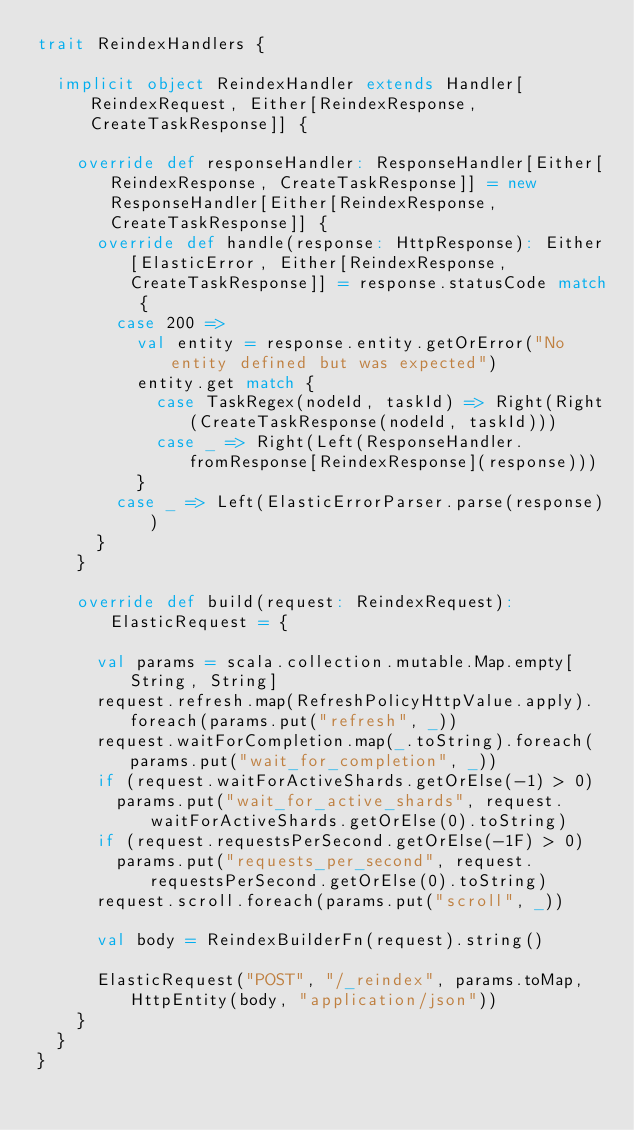<code> <loc_0><loc_0><loc_500><loc_500><_Scala_>trait ReindexHandlers {

  implicit object ReindexHandler extends Handler[ReindexRequest, Either[ReindexResponse, CreateTaskResponse]] {

    override def responseHandler: ResponseHandler[Either[ReindexResponse, CreateTaskResponse]] = new ResponseHandler[Either[ReindexResponse, CreateTaskResponse]] {
      override def handle(response: HttpResponse): Either[ElasticError, Either[ReindexResponse, CreateTaskResponse]] = response.statusCode match {
        case 200 =>
          val entity = response.entity.getOrError("No entity defined but was expected")
          entity.get match {
            case TaskRegex(nodeId, taskId) => Right(Right(CreateTaskResponse(nodeId, taskId)))
            case _ => Right(Left(ResponseHandler.fromResponse[ReindexResponse](response)))
          }
        case _ => Left(ElasticErrorParser.parse(response))
      }
    }

    override def build(request: ReindexRequest): ElasticRequest = {

      val params = scala.collection.mutable.Map.empty[String, String]
      request.refresh.map(RefreshPolicyHttpValue.apply).foreach(params.put("refresh", _))
      request.waitForCompletion.map(_.toString).foreach(params.put("wait_for_completion", _))
      if (request.waitForActiveShards.getOrElse(-1) > 0)
        params.put("wait_for_active_shards", request.waitForActiveShards.getOrElse(0).toString)
      if (request.requestsPerSecond.getOrElse(-1F) > 0)
        params.put("requests_per_second", request.requestsPerSecond.getOrElse(0).toString)
      request.scroll.foreach(params.put("scroll", _))

      val body = ReindexBuilderFn(request).string()

      ElasticRequest("POST", "/_reindex", params.toMap, HttpEntity(body, "application/json"))
    }
  }
}
</code> 